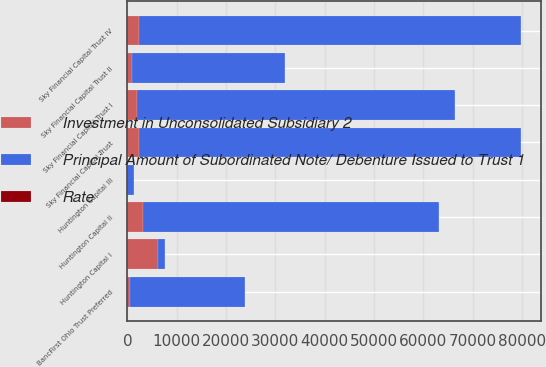Convert chart to OTSL. <chart><loc_0><loc_0><loc_500><loc_500><stacked_bar_chart><ecel><fcel>Huntington Capital I<fcel>Huntington Capital II<fcel>Huntington Capital III<fcel>BancFirst Ohio Trust Preferred<fcel>Sky Financial Capital Trust I<fcel>Sky Financial Capital Trust II<fcel>Sky Financial Capital Trust<fcel>Sky Financial Capital Trust IV<nl><fcel>Rate<fcel>0.99<fcel>0.93<fcel>6.69<fcel>8.54<fcel>8.52<fcel>3.52<fcel>1.29<fcel>1.28<nl><fcel>Principal Amount of Subordinated Note/ Debenture Issued to Trust 1<fcel>1392.5<fcel>60093<fcel>1392.5<fcel>23248<fcel>64474<fcel>30929<fcel>77481<fcel>77482<nl><fcel>Investment in Unconsolidated Subsidiary 2<fcel>6186<fcel>3093<fcel>10<fcel>619<fcel>1856<fcel>929<fcel>2320<fcel>2320<nl></chart> 